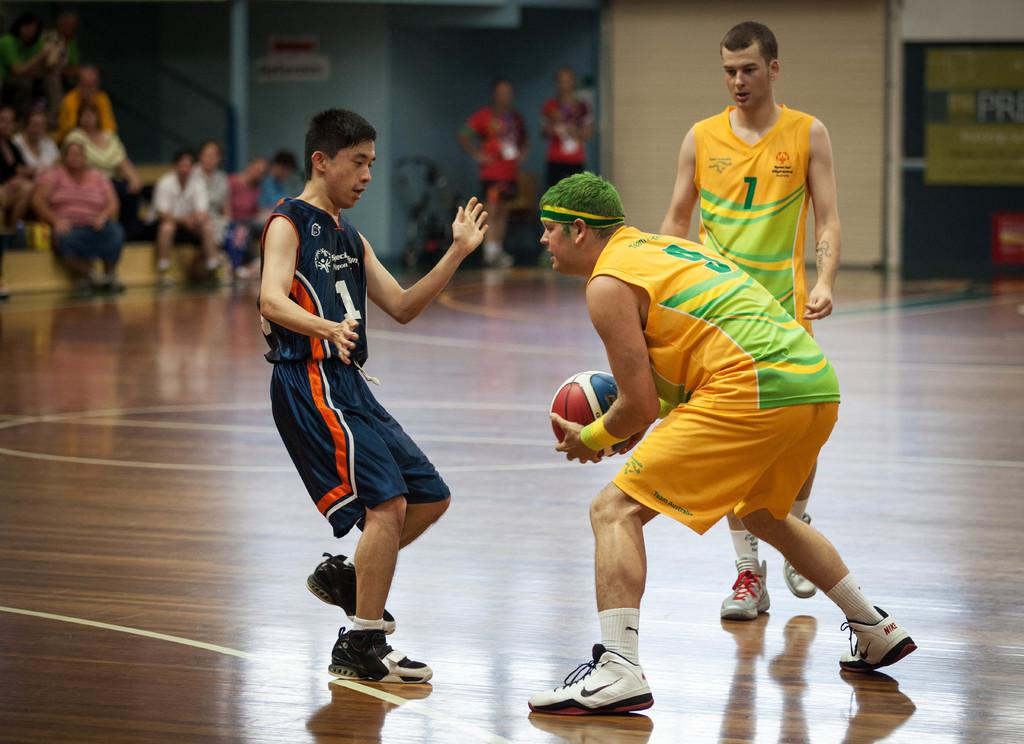What are the three people in the image doing? The three people are playing basketball. Who among them is holding the ball? One person is holding the ball. What can be observed about the people in the background? There are many people sitting in the background, and two persons are standing. What is the presence of a wall in the image? There is a wall visible in the image. What type of meat is being grilled by the frogs in the image? There are no frogs or meat present in the image; it features people playing basketball and a wall in the background. 